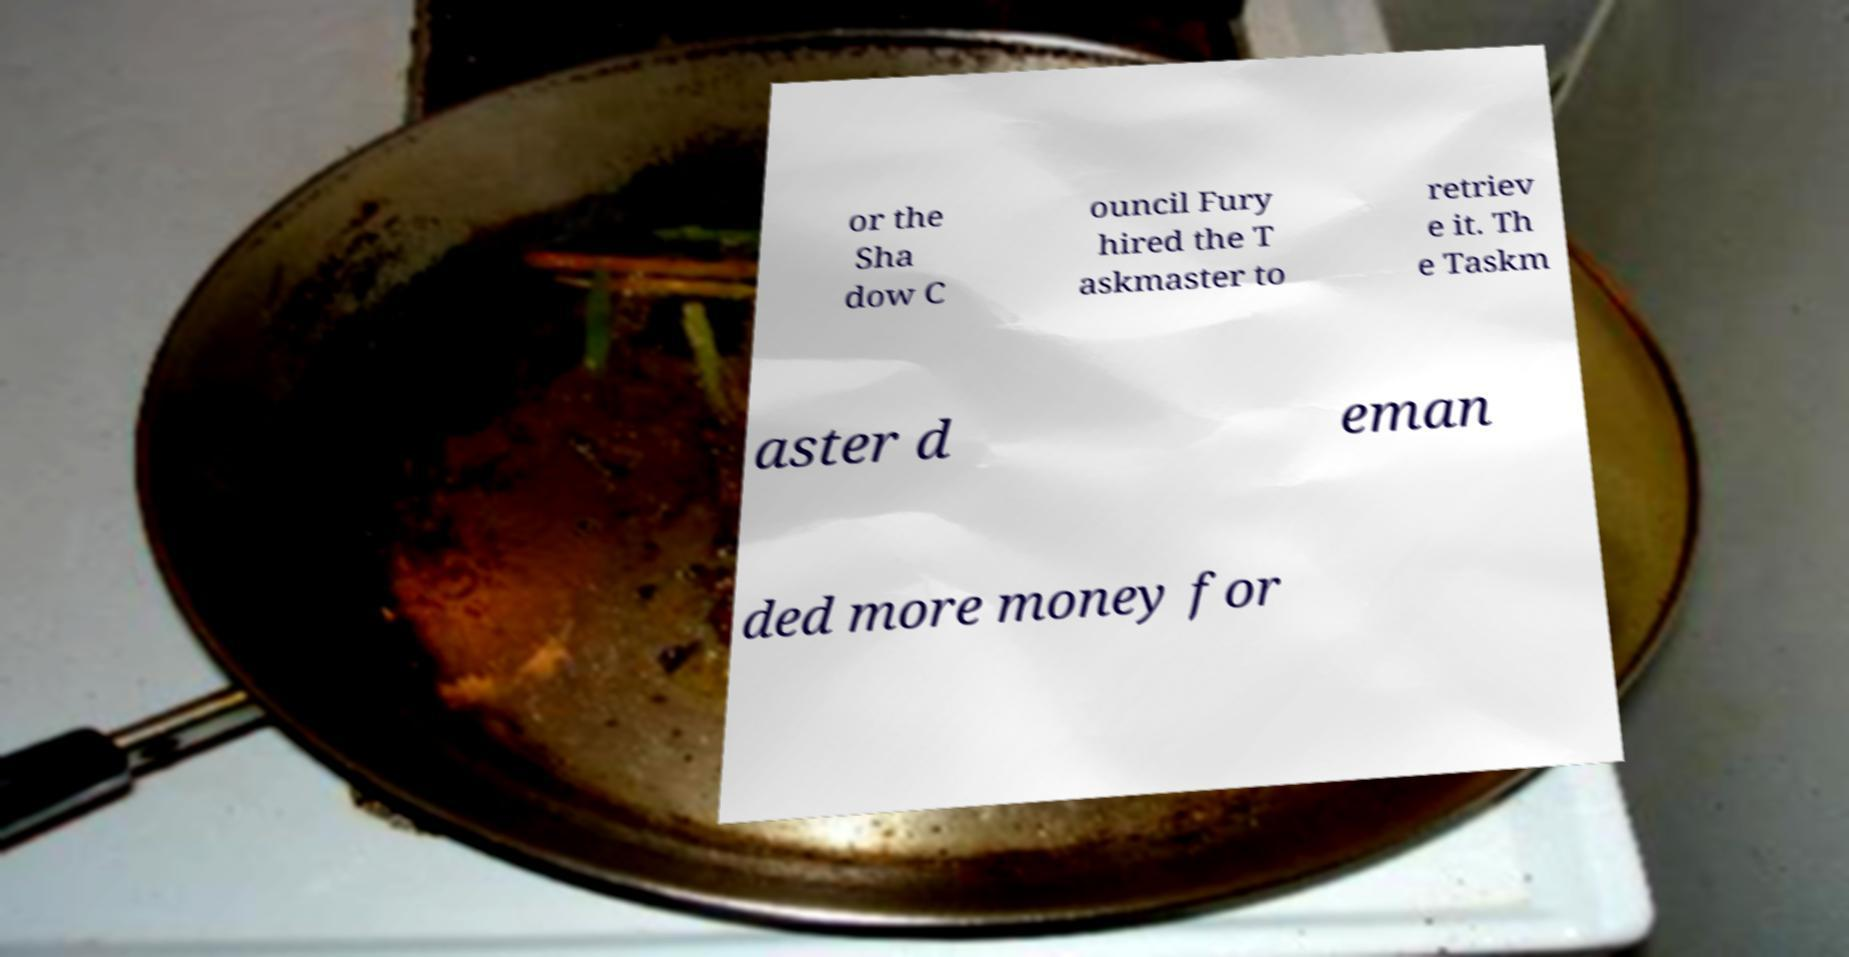What messages or text are displayed in this image? I need them in a readable, typed format. or the Sha dow C ouncil Fury hired the T askmaster to retriev e it. Th e Taskm aster d eman ded more money for 